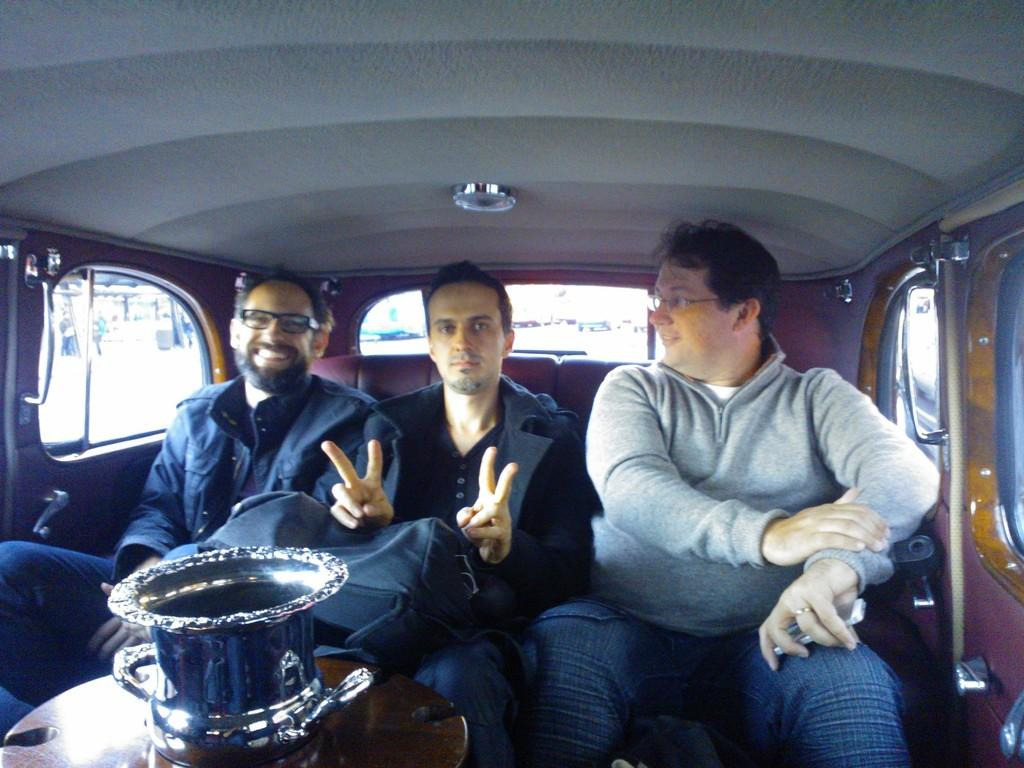How many people are in the image? There are three men in the image. Where are the men located in the image? The men are sitting inside a vehicle. What other object can be seen in the image besides the men? There is a table in the image. What is on the table in the image? There is a flask on the table. What type of bells can be heard ringing in the image? There are no bells present in the image, and therefore no sound can be heard. 